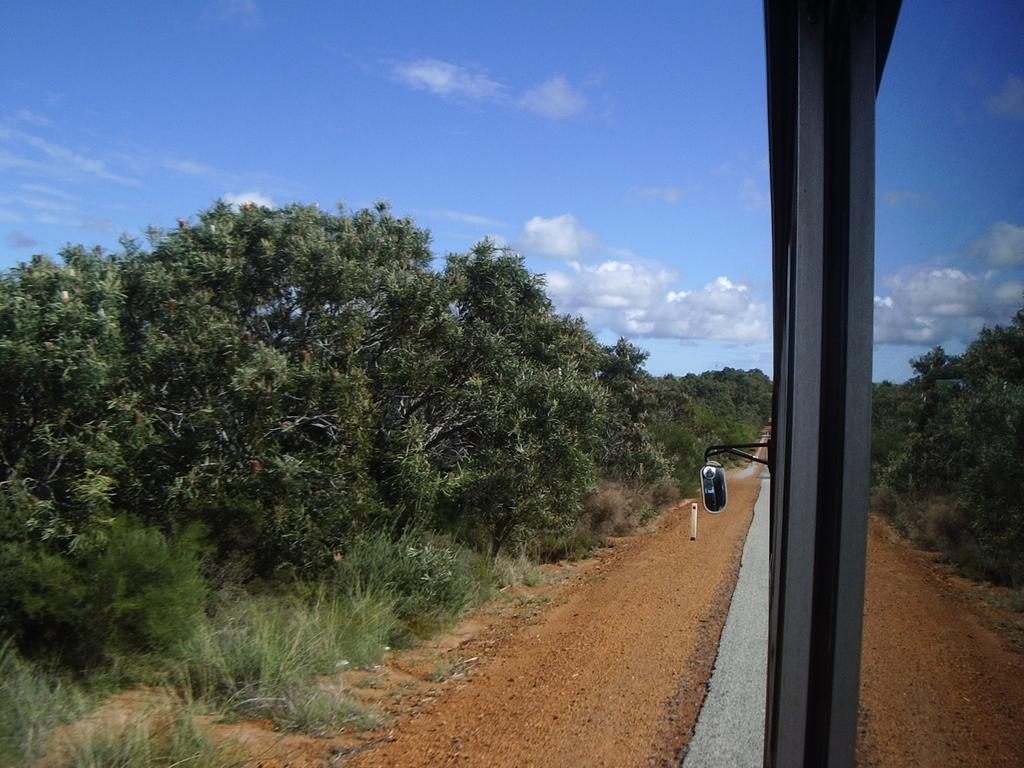What is on the road in the image? There is a vehicle on the road in the image. What can be seen near the road? There are small stones near the road. What type of vegetation is present in the image? There are trees, bushes, plants, and grass in the image. What is the condition of the sky in the image? The sky is cloudy in the image. What type of music can be heard playing from the vehicle in the image? There is no indication of music playing from the vehicle in the image, as it only shows the vehicle on the road. 